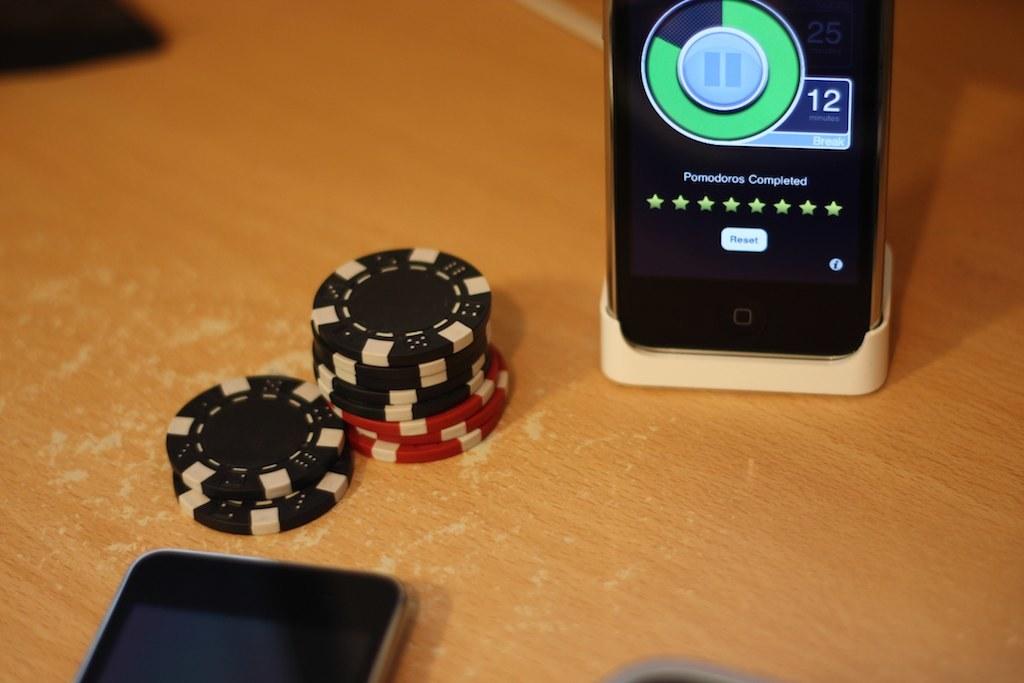What number is displayed on the phone?
Ensure brevity in your answer.  12. 